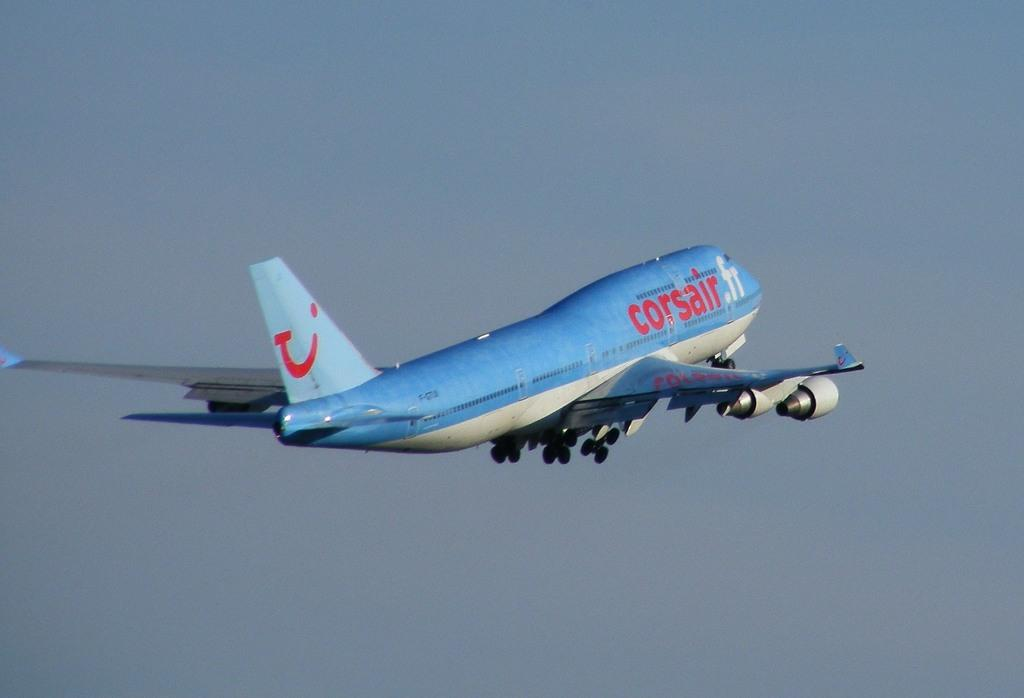What is the main subject of the image? The main subject of the image is a plane. What is the plane doing in the image? The plane is flying in the air. What features can be seen on the plane? The plane has wings. What can be seen in the background of the image? The sky is visible in the background of the image. What is the color of the sky in the image? The sky is blue in color. Where is the lettuce being served in the image? There is no lettuce present in the image; it features a plane flying in the air. What type of oil is being used to lubricate the station in the image? There is no station or oil present in the image; it only shows a plane flying in the sky. 